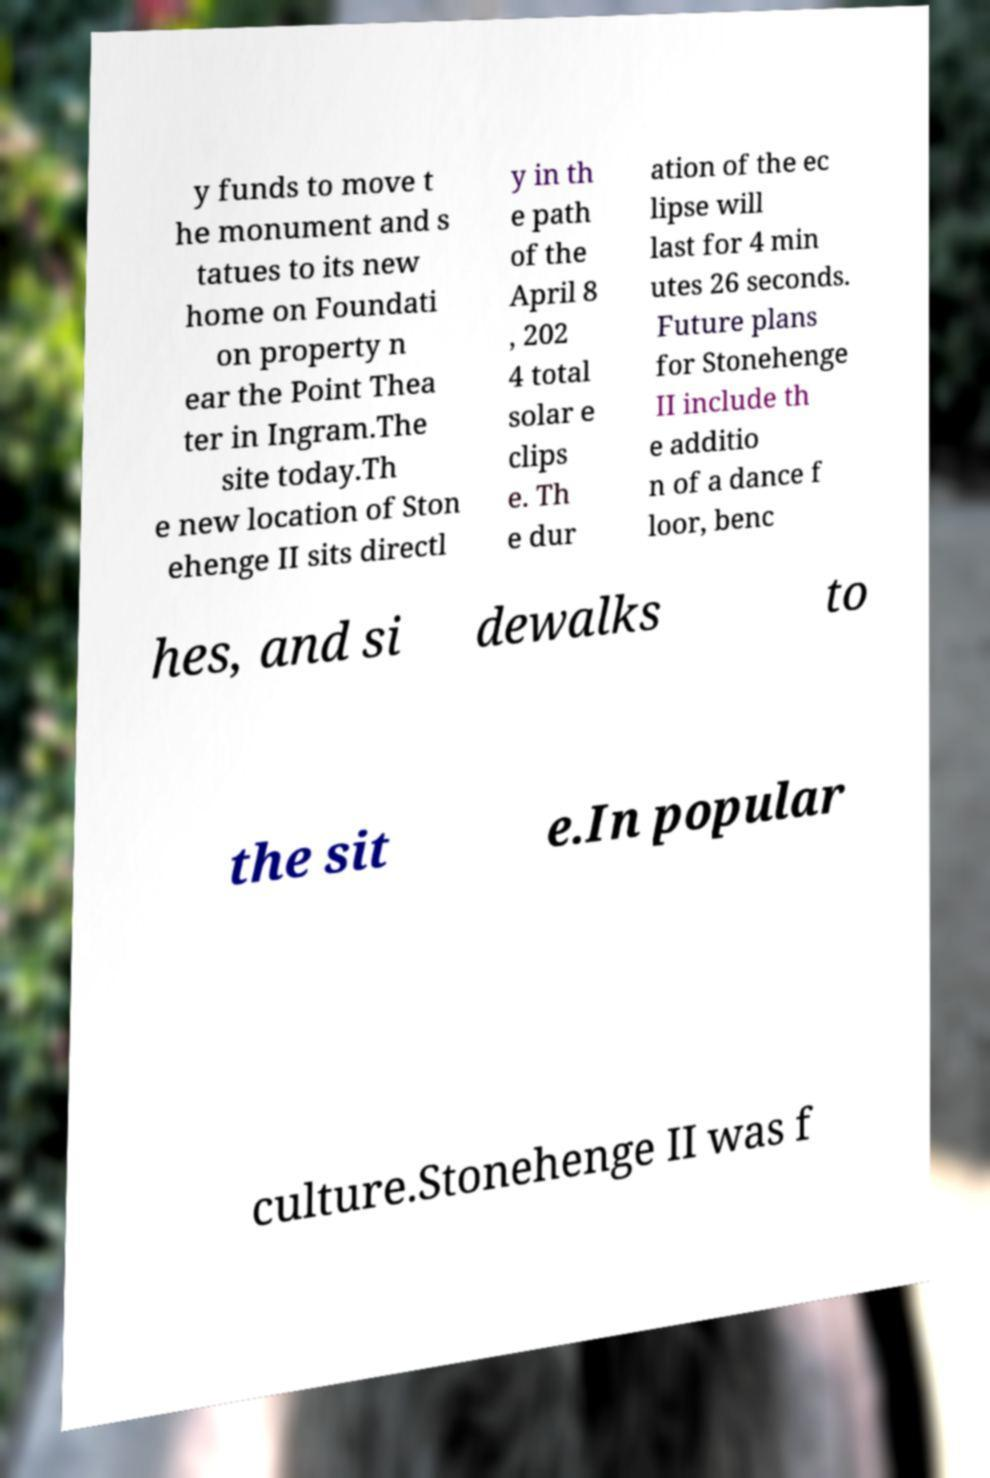Can you accurately transcribe the text from the provided image for me? y funds to move t he monument and s tatues to its new home on Foundati on property n ear the Point Thea ter in Ingram.The site today.Th e new location of Ston ehenge II sits directl y in th e path of the April 8 , 202 4 total solar e clips e. Th e dur ation of the ec lipse will last for 4 min utes 26 seconds. Future plans for Stonehenge II include th e additio n of a dance f loor, benc hes, and si dewalks to the sit e.In popular culture.Stonehenge II was f 